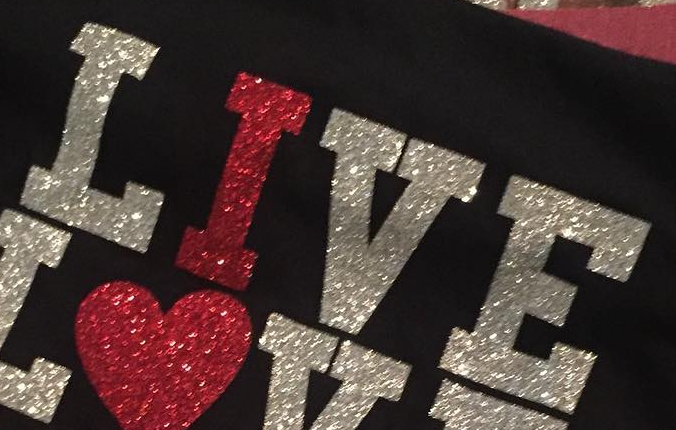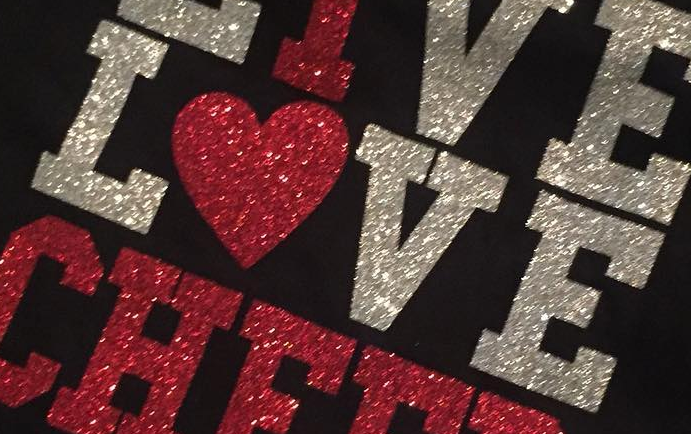What words are shown in these images in order, separated by a semicolon? LIVE; LOVE 